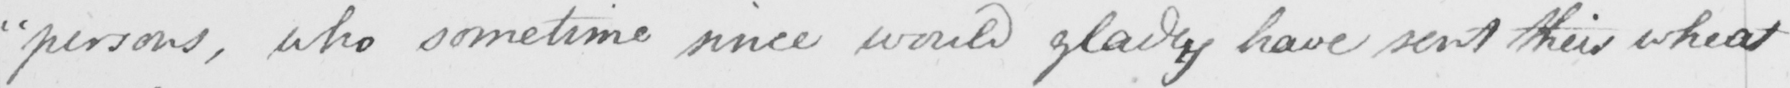What text is written in this handwritten line? " persons , who sometime since would gladly have sent their wheat 